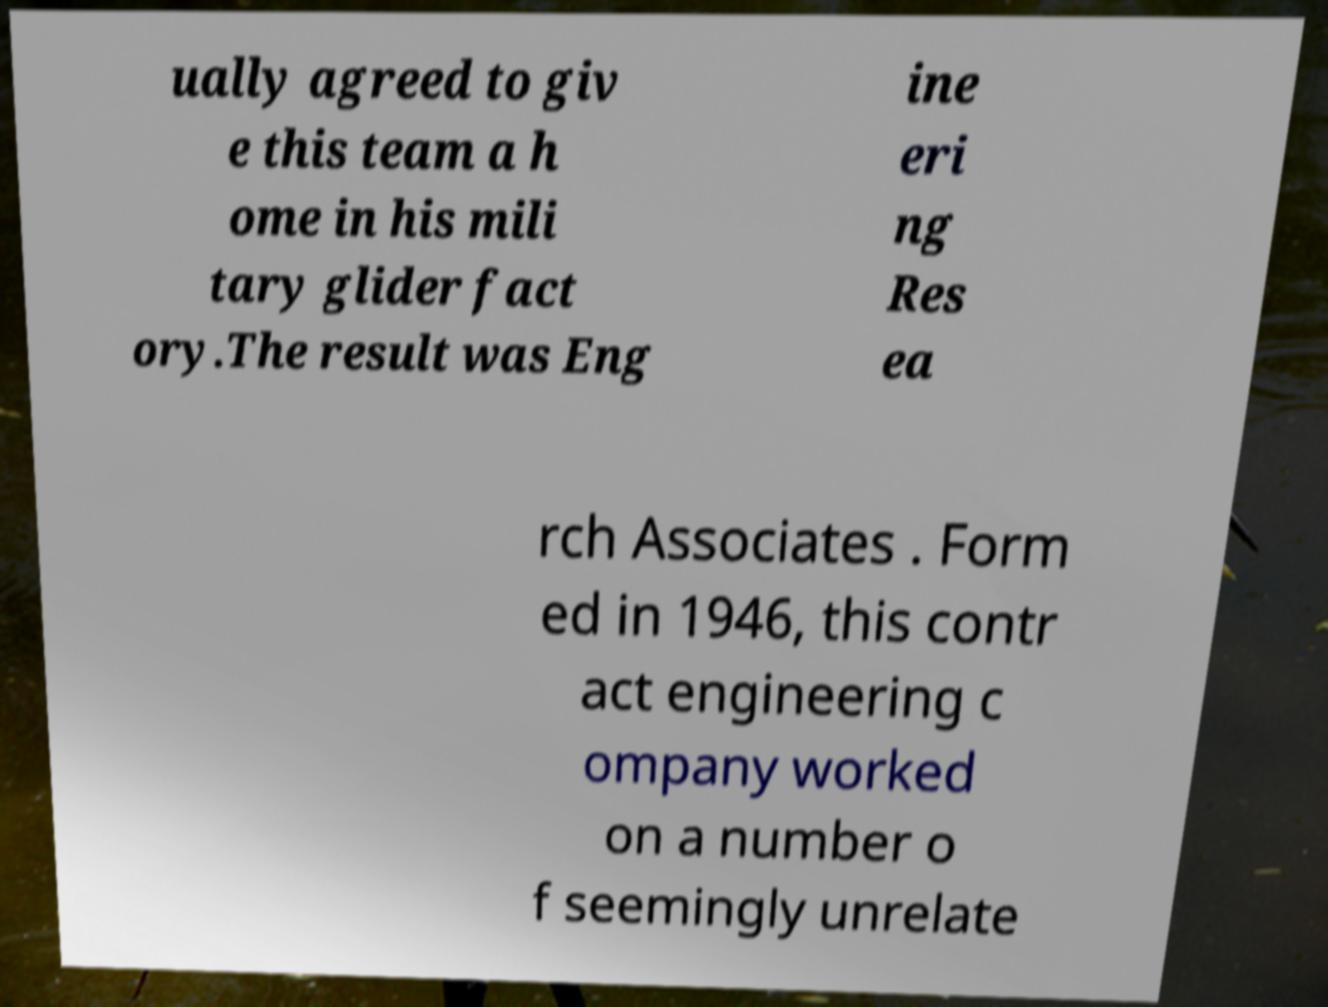Please read and relay the text visible in this image. What does it say? ually agreed to giv e this team a h ome in his mili tary glider fact ory.The result was Eng ine eri ng Res ea rch Associates . Form ed in 1946, this contr act engineering c ompany worked on a number o f seemingly unrelate 